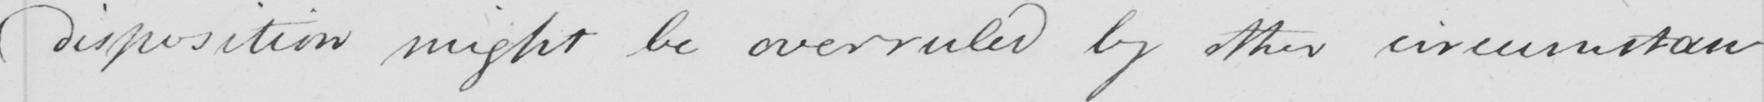What text is written in this handwritten line? disposition might be overruled by other circumstances . 